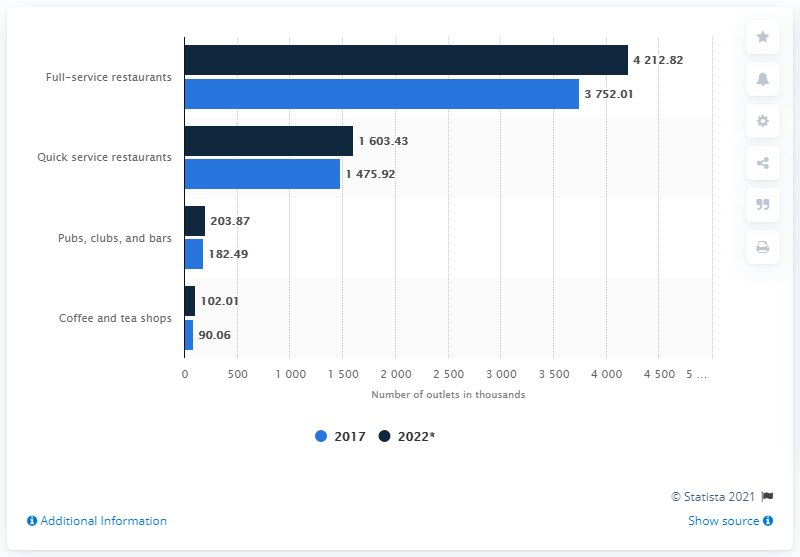List a handful of essential elements in this visual. The difference between the highest and the lowest dark blue bar is 4110.81. The difference between the shortest light blue bar and the longest dark blue bar is -4122.76... 